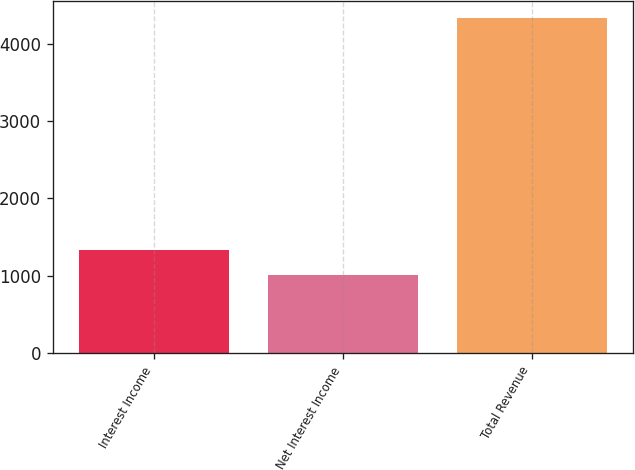Convert chart to OTSL. <chart><loc_0><loc_0><loc_500><loc_500><bar_chart><fcel>Interest Income<fcel>Net Interest Income<fcel>Total Revenue<nl><fcel>1338.07<fcel>1005.5<fcel>4331.2<nl></chart> 